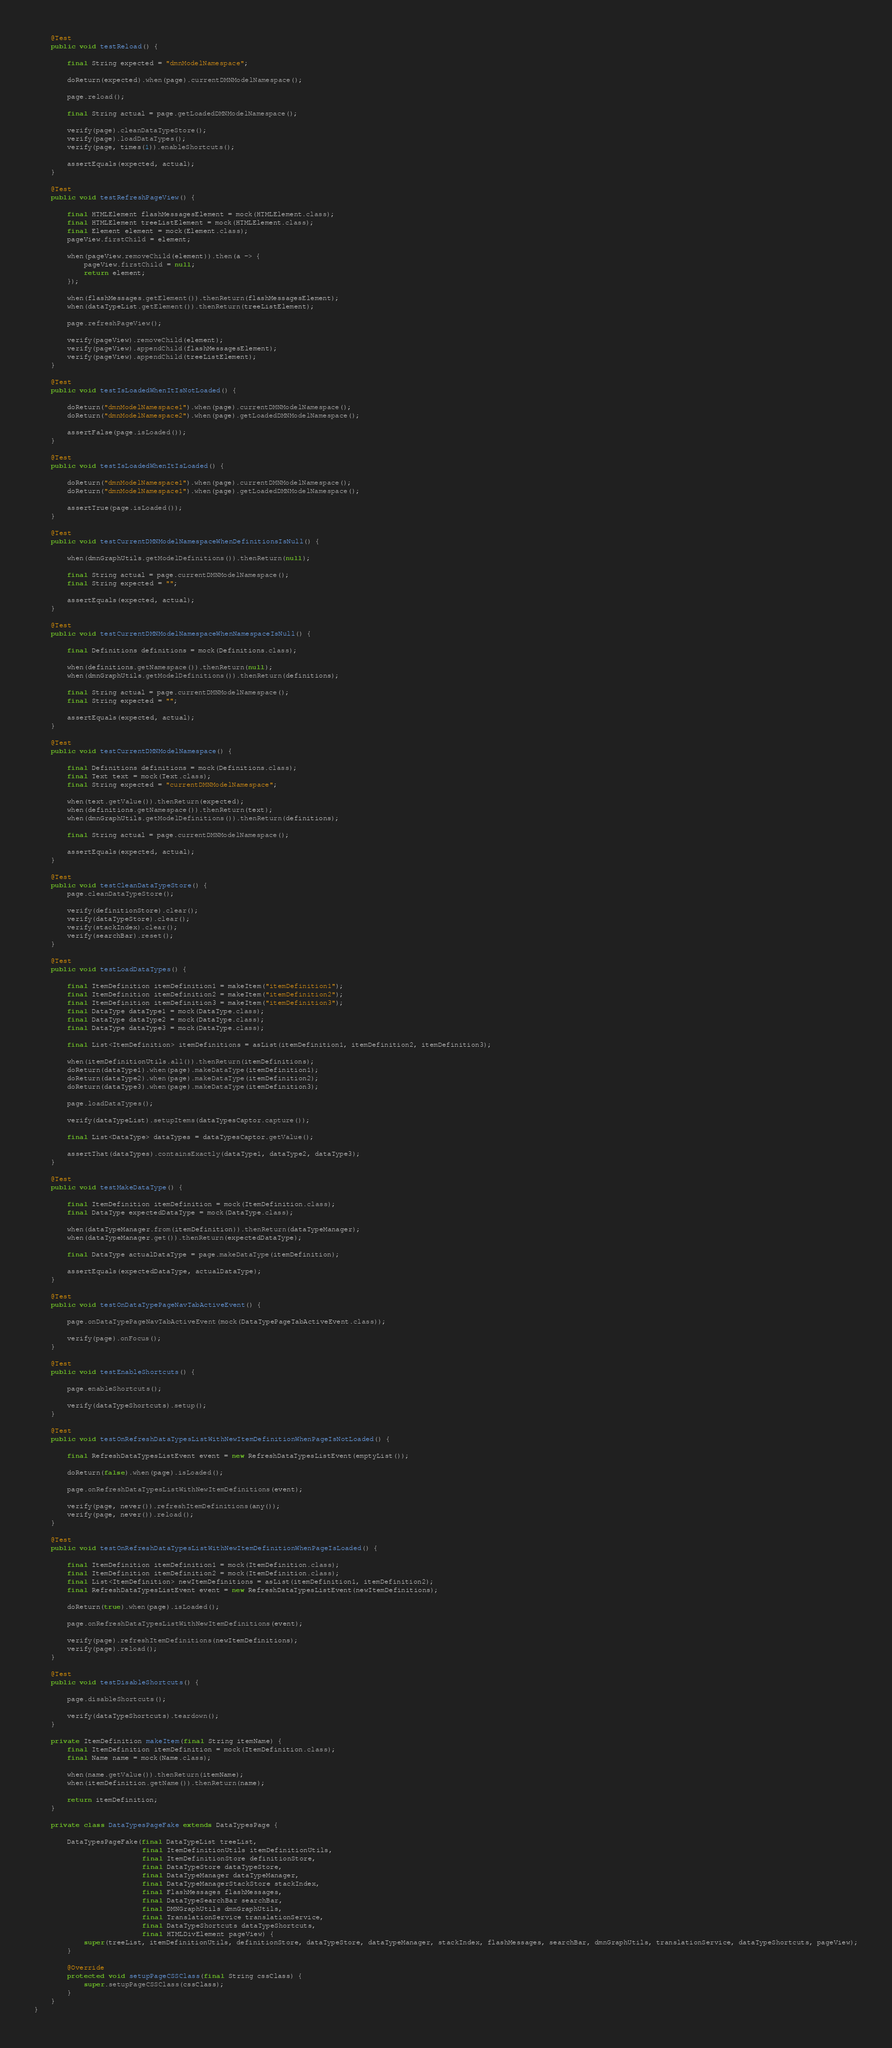Convert code to text. <code><loc_0><loc_0><loc_500><loc_500><_Java_>    @Test
    public void testReload() {

        final String expected = "dmnModelNamespace";

        doReturn(expected).when(page).currentDMNModelNamespace();

        page.reload();

        final String actual = page.getLoadedDMNModelNamespace();

        verify(page).cleanDataTypeStore();
        verify(page).loadDataTypes();
        verify(page, times(1)).enableShortcuts();

        assertEquals(expected, actual);
    }

    @Test
    public void testRefreshPageView() {

        final HTMLElement flashMessagesElement = mock(HTMLElement.class);
        final HTMLElement treeListElement = mock(HTMLElement.class);
        final Element element = mock(Element.class);
        pageView.firstChild = element;

        when(pageView.removeChild(element)).then(a -> {
            pageView.firstChild = null;
            return element;
        });

        when(flashMessages.getElement()).thenReturn(flashMessagesElement);
        when(dataTypeList.getElement()).thenReturn(treeListElement);

        page.refreshPageView();

        verify(pageView).removeChild(element);
        verify(pageView).appendChild(flashMessagesElement);
        verify(pageView).appendChild(treeListElement);
    }

    @Test
    public void testIsLoadedWhenItIsNotLoaded() {

        doReturn("dmnModelNamespace1").when(page).currentDMNModelNamespace();
        doReturn("dmnModelNamespace2").when(page).getLoadedDMNModelNamespace();

        assertFalse(page.isLoaded());
    }

    @Test
    public void testIsLoadedWhenItIsLoaded() {

        doReturn("dmnModelNamespace1").when(page).currentDMNModelNamespace();
        doReturn("dmnModelNamespace1").when(page).getLoadedDMNModelNamespace();

        assertTrue(page.isLoaded());
    }

    @Test
    public void testCurrentDMNModelNamespaceWhenDefinitionsIsNull() {

        when(dmnGraphUtils.getModelDefinitions()).thenReturn(null);

        final String actual = page.currentDMNModelNamespace();
        final String expected = "";

        assertEquals(expected, actual);
    }

    @Test
    public void testCurrentDMNModelNamespaceWhenNamespaceIsNull() {

        final Definitions definitions = mock(Definitions.class);

        when(definitions.getNamespace()).thenReturn(null);
        when(dmnGraphUtils.getModelDefinitions()).thenReturn(definitions);

        final String actual = page.currentDMNModelNamespace();
        final String expected = "";

        assertEquals(expected, actual);
    }

    @Test
    public void testCurrentDMNModelNamespace() {

        final Definitions definitions = mock(Definitions.class);
        final Text text = mock(Text.class);
        final String expected = "currentDMNModelNamespace";

        when(text.getValue()).thenReturn(expected);
        when(definitions.getNamespace()).thenReturn(text);
        when(dmnGraphUtils.getModelDefinitions()).thenReturn(definitions);

        final String actual = page.currentDMNModelNamespace();

        assertEquals(expected, actual);
    }

    @Test
    public void testCleanDataTypeStore() {
        page.cleanDataTypeStore();

        verify(definitionStore).clear();
        verify(dataTypeStore).clear();
        verify(stackIndex).clear();
        verify(searchBar).reset();
    }

    @Test
    public void testLoadDataTypes() {

        final ItemDefinition itemDefinition1 = makeItem("itemDefinition1");
        final ItemDefinition itemDefinition2 = makeItem("itemDefinition2");
        final ItemDefinition itemDefinition3 = makeItem("itemDefinition3");
        final DataType dataType1 = mock(DataType.class);
        final DataType dataType2 = mock(DataType.class);
        final DataType dataType3 = mock(DataType.class);

        final List<ItemDefinition> itemDefinitions = asList(itemDefinition1, itemDefinition2, itemDefinition3);

        when(itemDefinitionUtils.all()).thenReturn(itemDefinitions);
        doReturn(dataType1).when(page).makeDataType(itemDefinition1);
        doReturn(dataType2).when(page).makeDataType(itemDefinition2);
        doReturn(dataType3).when(page).makeDataType(itemDefinition3);

        page.loadDataTypes();

        verify(dataTypeList).setupItems(dataTypesCaptor.capture());

        final List<DataType> dataTypes = dataTypesCaptor.getValue();

        assertThat(dataTypes).containsExactly(dataType1, dataType2, dataType3);
    }

    @Test
    public void testMakeDataType() {

        final ItemDefinition itemDefinition = mock(ItemDefinition.class);
        final DataType expectedDataType = mock(DataType.class);

        when(dataTypeManager.from(itemDefinition)).thenReturn(dataTypeManager);
        when(dataTypeManager.get()).thenReturn(expectedDataType);

        final DataType actualDataType = page.makeDataType(itemDefinition);

        assertEquals(expectedDataType, actualDataType);
    }

    @Test
    public void testOnDataTypePageNavTabActiveEvent() {

        page.onDataTypePageNavTabActiveEvent(mock(DataTypePageTabActiveEvent.class));

        verify(page).onFocus();
    }

    @Test
    public void testEnableShortcuts() {

        page.enableShortcuts();

        verify(dataTypeShortcuts).setup();
    }

    @Test
    public void testOnRefreshDataTypesListWithNewItemDefinitionWhenPageIsNotLoaded() {

        final RefreshDataTypesListEvent event = new RefreshDataTypesListEvent(emptyList());

        doReturn(false).when(page).isLoaded();

        page.onRefreshDataTypesListWithNewItemDefinitions(event);

        verify(page, never()).refreshItemDefinitions(any());
        verify(page, never()).reload();
    }

    @Test
    public void testOnRefreshDataTypesListWithNewItemDefinitionWhenPageIsLoaded() {

        final ItemDefinition itemDefinition1 = mock(ItemDefinition.class);
        final ItemDefinition itemDefinition2 = mock(ItemDefinition.class);
        final List<ItemDefinition> newItemDefinitions = asList(itemDefinition1, itemDefinition2);
        final RefreshDataTypesListEvent event = new RefreshDataTypesListEvent(newItemDefinitions);

        doReturn(true).when(page).isLoaded();

        page.onRefreshDataTypesListWithNewItemDefinitions(event);

        verify(page).refreshItemDefinitions(newItemDefinitions);
        verify(page).reload();
    }

    @Test
    public void testDisableShortcuts() {

        page.disableShortcuts();

        verify(dataTypeShortcuts).teardown();
    }

    private ItemDefinition makeItem(final String itemName) {
        final ItemDefinition itemDefinition = mock(ItemDefinition.class);
        final Name name = mock(Name.class);

        when(name.getValue()).thenReturn(itemName);
        when(itemDefinition.getName()).thenReturn(name);

        return itemDefinition;
    }

    private class DataTypesPageFake extends DataTypesPage {

        DataTypesPageFake(final DataTypeList treeList,
                          final ItemDefinitionUtils itemDefinitionUtils,
                          final ItemDefinitionStore definitionStore,
                          final DataTypeStore dataTypeStore,
                          final DataTypeManager dataTypeManager,
                          final DataTypeManagerStackStore stackIndex,
                          final FlashMessages flashMessages,
                          final DataTypeSearchBar searchBar,
                          final DMNGraphUtils dmnGraphUtils,
                          final TranslationService translationService,
                          final DataTypeShortcuts dataTypeShortcuts,
                          final HTMLDivElement pageView) {
            super(treeList, itemDefinitionUtils, definitionStore, dataTypeStore, dataTypeManager, stackIndex, flashMessages, searchBar, dmnGraphUtils, translationService, dataTypeShortcuts, pageView);
        }

        @Override
        protected void setupPageCSSClass(final String cssClass) {
            super.setupPageCSSClass(cssClass);
        }
    }
}

</code> 